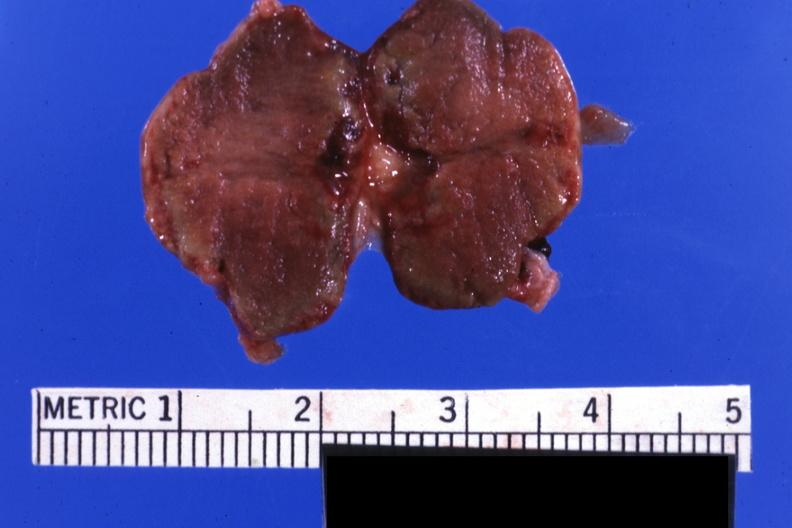s pituitary present?
Answer the question using a single word or phrase. Yes 